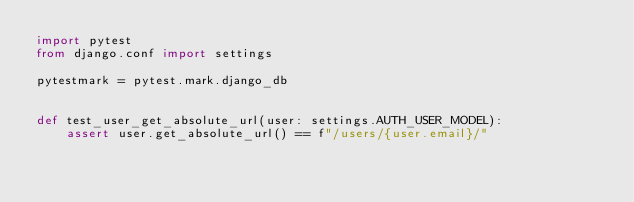<code> <loc_0><loc_0><loc_500><loc_500><_Python_>import pytest
from django.conf import settings

pytestmark = pytest.mark.django_db


def test_user_get_absolute_url(user: settings.AUTH_USER_MODEL):
    assert user.get_absolute_url() == f"/users/{user.email}/"
</code> 